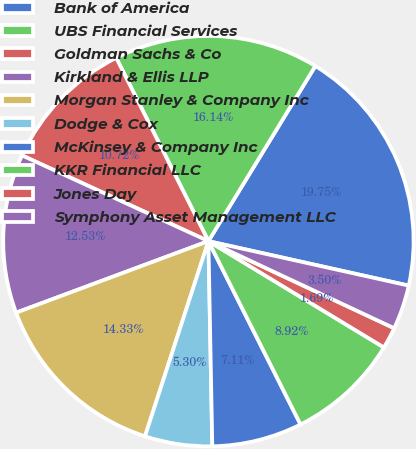<chart> <loc_0><loc_0><loc_500><loc_500><pie_chart><fcel>Bank of America<fcel>UBS Financial Services<fcel>Goldman Sachs & Co<fcel>Kirkland & Ellis LLP<fcel>Morgan Stanley & Company Inc<fcel>Dodge & Cox<fcel>McKinsey & Company Inc<fcel>KKR Financial LLC<fcel>Jones Day<fcel>Symphony Asset Management LLC<nl><fcel>19.75%<fcel>16.14%<fcel>10.72%<fcel>12.53%<fcel>14.33%<fcel>5.3%<fcel>7.11%<fcel>8.92%<fcel>1.69%<fcel>3.5%<nl></chart> 